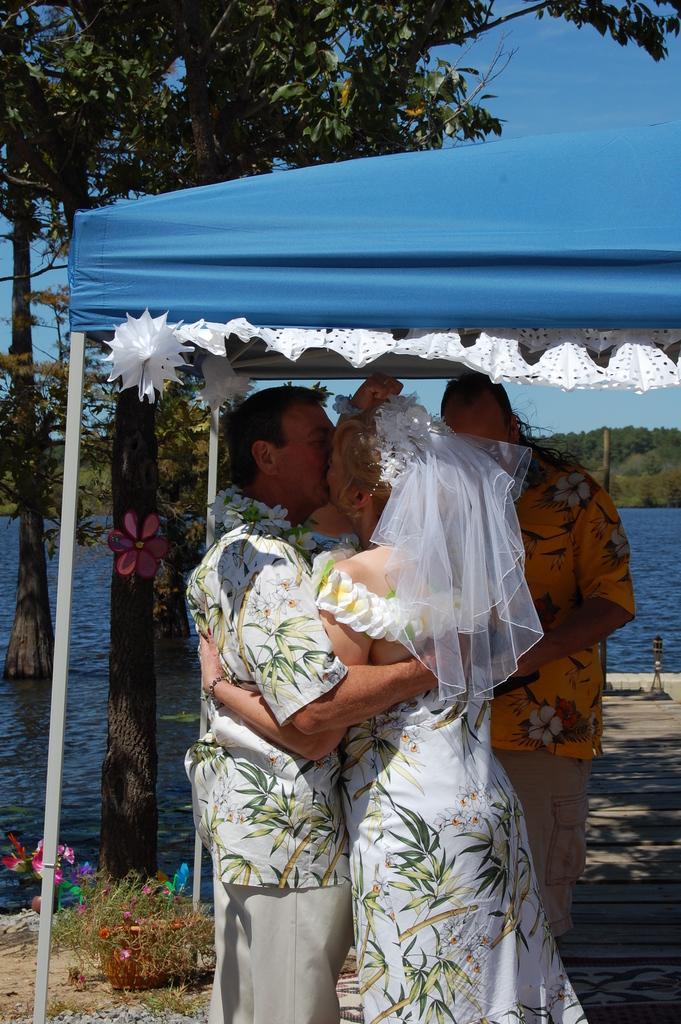Could you give a brief overview of what you see in this image? In this image there is a couple kissing under the tent, beside them there is another man standing and also there is a lake and trees. 